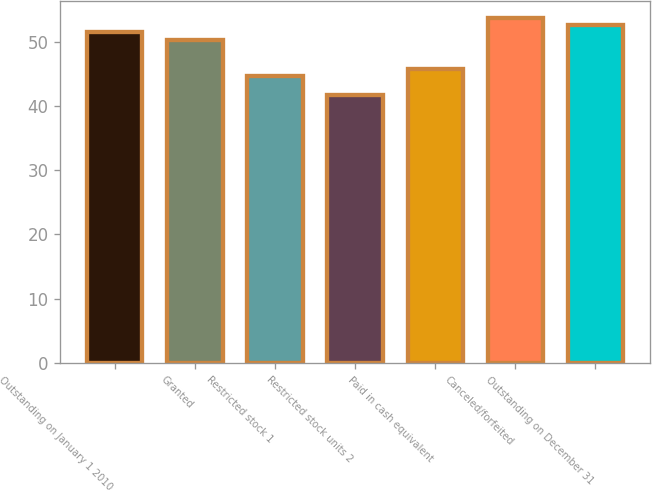Convert chart. <chart><loc_0><loc_0><loc_500><loc_500><bar_chart><fcel>Outstanding on January 1 2010<fcel>Granted<fcel>Restricted stock 1<fcel>Restricted stock units 2<fcel>Paid in cash equivalent<fcel>Canceled/forfeited<fcel>Outstanding on December 31<nl><fcel>51.45<fcel>50.33<fcel>44.62<fcel>41.77<fcel>45.74<fcel>53.69<fcel>52.57<nl></chart> 